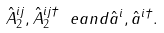<formula> <loc_0><loc_0><loc_500><loc_500>\hat { A } _ { 2 } ^ { i j } , \hat { A } _ { 2 } ^ { i j \dagger } \ e a n d \hat { a } ^ { i } , \hat { a } ^ { i \dagger } .</formula> 